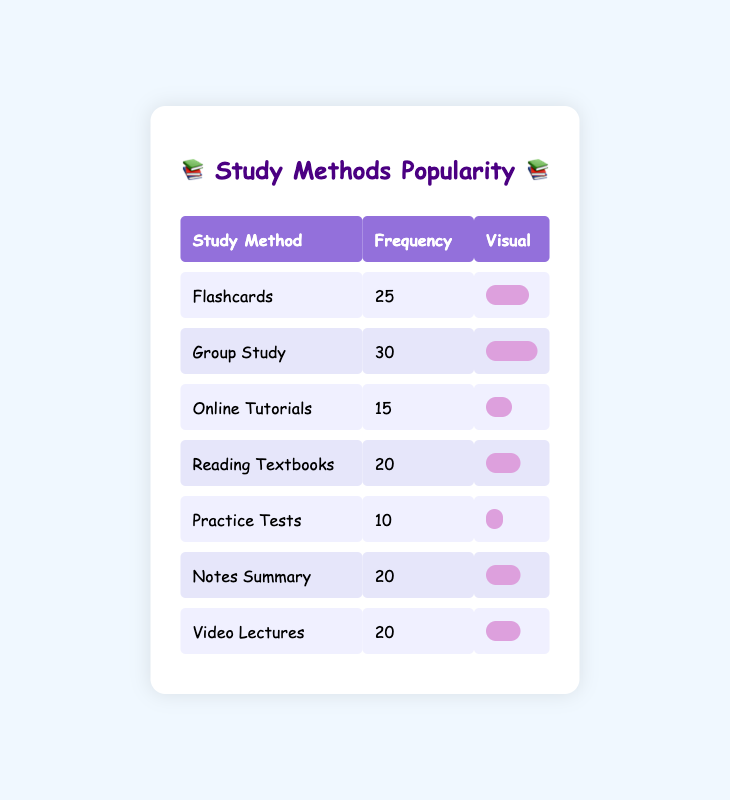What is the most preferred study method among high school students? Looking at the frequency column, "Group Study" has the highest frequency of 30, which indicates it's the most preferred method.
Answer: Group Study How many students prefer Flashcards as their study method? The frequency for Flashcards is given directly in the table as 25, which means 25 students prefer this method.
Answer: 25 What is the combined frequency of those who prefer Reading Textbooks and Video Lectures? To find the combined frequency, we add the frequencies of Reading Textbooks (20) and Video Lectures (20), giving us 20 + 20 = 40.
Answer: 40 Is the frequency of Online Tutorials higher than that of Practice Tests? The frequency for Online Tutorials is 15 and for Practice Tests is 10. Since 15 is greater than 10, Online Tutorials has a higher frequency.
Answer: Yes What is the average frequency of the study methods listed in the table? To find the average, we first calculate the total frequency: 25 + 30 + 15 + 20 + 10 + 20 + 20 = 130. Then, we divide by the number of methods, which is 7. So, the average is 130 / 7 ≈ 18.57.
Answer: 18.57 What is the difference in frequency between the most and least preferred study methods? The most preferred method is Group Study with a frequency of 30, and the least preferred is Practice Tests with a frequency of 10. The difference is 30 - 10 = 20.
Answer: 20 Which study methods have the same frequency? By examining the frequency values, we see that Notes Summary, Video Lectures, and Reading Textbooks all have a frequency of 20. Therefore, these methods share the same frequency.
Answer: Notes Summary, Video Lectures, Reading Textbooks How many students prefer study methods that utilize both online resources (Online Tutorials and Video Lectures)? The frequency for Online Tutorials is 15 and for Video Lectures is 20. The total for both methods is 15 + 20 = 35.
Answer: 35 Are there more students who prefer Group Study than those who prefer Flashcards? The frequency for Group Study is 30 and for Flashcards is 25. Since 30 is greater than 25, more students prefer Group Study.
Answer: Yes 